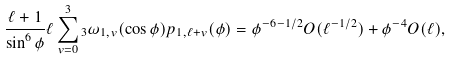Convert formula to latex. <formula><loc_0><loc_0><loc_500><loc_500>\frac { \ell + 1 } { \sin ^ { 6 } \phi } \ell \sum _ { v = 0 } ^ { 3 } { _ { 3 } } \omega _ { 1 , v } ( \cos \phi ) p _ { 1 , \ell + v } ( \phi ) = \phi ^ { - 6 - 1 / 2 } O ( \ell ^ { - 1 / 2 } ) + \phi ^ { - 4 } O ( \ell ) ,</formula> 